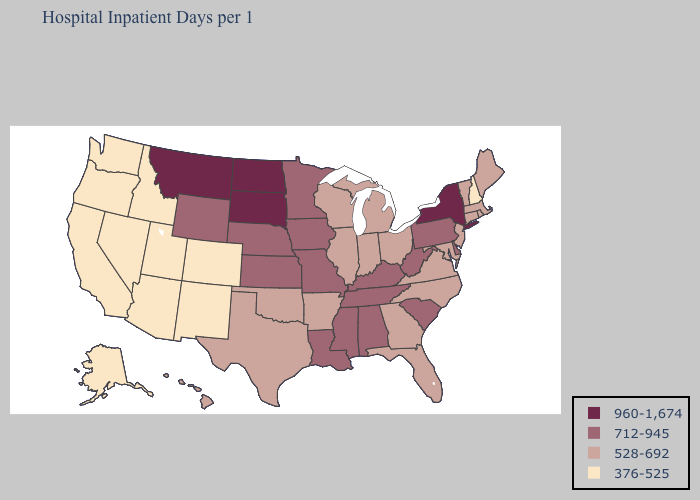Does the map have missing data?
Short answer required. No. Name the states that have a value in the range 376-525?
Answer briefly. Alaska, Arizona, California, Colorado, Idaho, Nevada, New Hampshire, New Mexico, Oregon, Utah, Washington. What is the value of Kentucky?
Give a very brief answer. 712-945. Does Massachusetts have the lowest value in the USA?
Short answer required. No. How many symbols are there in the legend?
Answer briefly. 4. What is the value of Michigan?
Short answer required. 528-692. Among the states that border Indiana , which have the highest value?
Concise answer only. Kentucky. Does South Dakota have the lowest value in the USA?
Short answer required. No. Among the states that border Alabama , does Florida have the lowest value?
Answer briefly. Yes. Name the states that have a value in the range 960-1,674?
Give a very brief answer. Montana, New York, North Dakota, South Dakota. What is the highest value in states that border Delaware?
Keep it brief. 712-945. Which states hav the highest value in the West?
Keep it brief. Montana. What is the value of Colorado?
Keep it brief. 376-525. What is the value of Montana?
Concise answer only. 960-1,674. What is the highest value in the West ?
Quick response, please. 960-1,674. 